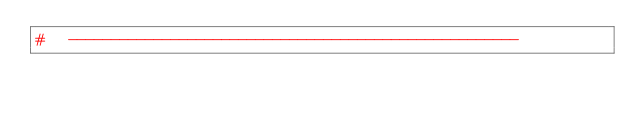<code> <loc_0><loc_0><loc_500><loc_500><_Python_>#	-----------------------------------------------------
</code> 